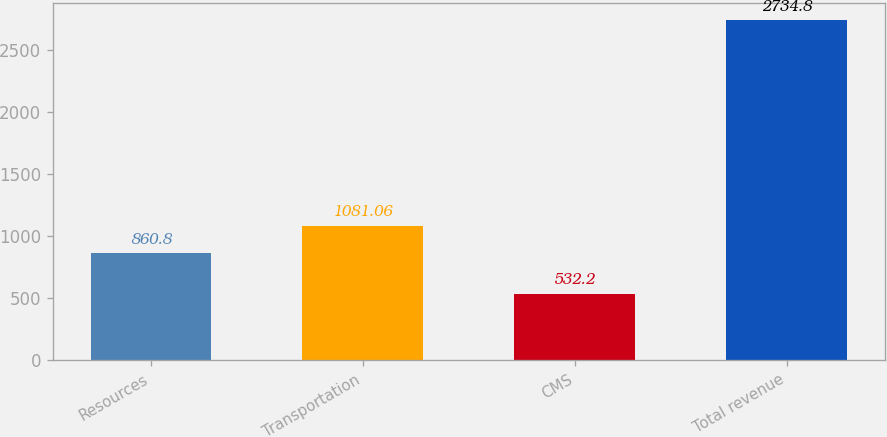Convert chart to OTSL. <chart><loc_0><loc_0><loc_500><loc_500><bar_chart><fcel>Resources<fcel>Transportation<fcel>CMS<fcel>Total revenue<nl><fcel>860.8<fcel>1081.06<fcel>532.2<fcel>2734.8<nl></chart> 